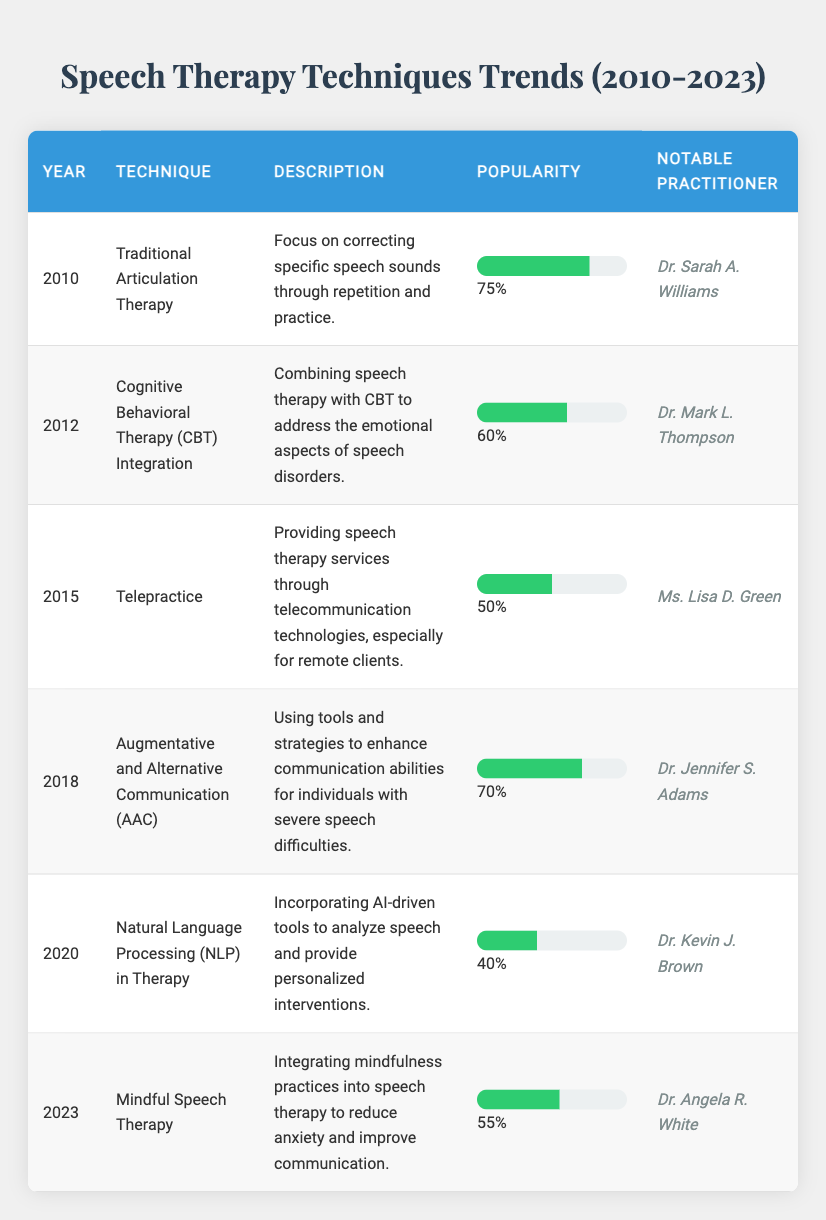What was the most popular speech therapy technique in 2010? According to the table, the most popular technique in 2010 was "Traditional Articulation Therapy," with a popularity percentage of 75%.
Answer: Traditional Articulation Therapy Which practitioner is associated with the technique "Augmentative and Alternative Communication (AAC)"? The table shows that "Augmentative and Alternative Communication (AAC)" is associated with Dr. Jennifer S. Adams as the notable practitioner.
Answer: Dr. Jennifer S. Adams What is the average popularity percentage of the techniques listed from 2010 to 2023? To find the average, sum the popularity percentages: (75 + 60 + 50 + 70 + 40 + 55) = 350. There are 6 techniques, so the average is 350/6 = 58.33%.
Answer: 58.33% Is "Telepractice" more popular than "Natural Language Processing (NLP) in Therapy"? Comparing the popularity percentages, "Telepractice" has a percentage of 50%, while "Natural Language Processing (NLP) in Therapy" has 40%. Since 50% is greater than 40%, the statement is true.
Answer: Yes Which technique saw an increase in popularity after 2018? From the table, popularity percentages indicate "Mindful Speech Therapy" in 2023 with a popularity of 55%, but prior techniques were lower in comparison: "Natural Language Processing" was at 40%, suggesting growth. Thus, there was no increase after 2018 compared to earlier techniques because earlier values were higher.
Answer: No 